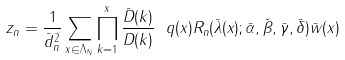Convert formula to latex. <formula><loc_0><loc_0><loc_500><loc_500>z _ { n } = \frac { 1 } { \bar { d } _ { n } ^ { 2 } } \sum _ { x \in \Lambda _ { N } } \prod _ { k = 1 } ^ { x } \frac { \bar { D } ( k ) } { D ( k ) } \ q ( x ) R _ { n } ( \bar { \lambda } ( x ) ; \bar { \alpha } , \bar { \beta } , \bar { \gamma } , \bar { \delta } ) \bar { w } ( x )</formula> 